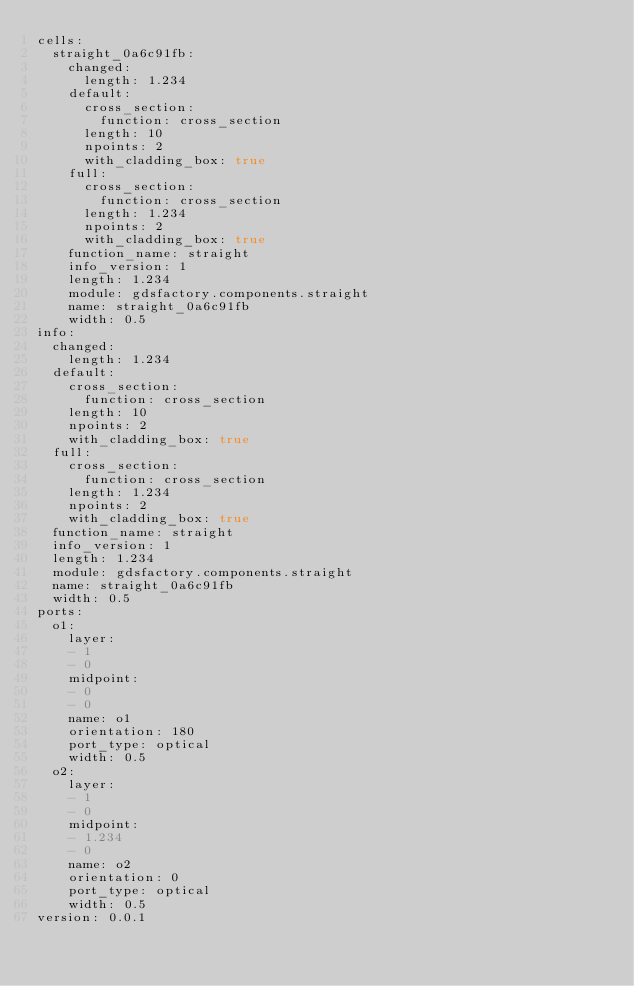<code> <loc_0><loc_0><loc_500><loc_500><_YAML_>cells:
  straight_0a6c91fb:
    changed:
      length: 1.234
    default:
      cross_section:
        function: cross_section
      length: 10
      npoints: 2
      with_cladding_box: true
    full:
      cross_section:
        function: cross_section
      length: 1.234
      npoints: 2
      with_cladding_box: true
    function_name: straight
    info_version: 1
    length: 1.234
    module: gdsfactory.components.straight
    name: straight_0a6c91fb
    width: 0.5
info:
  changed:
    length: 1.234
  default:
    cross_section:
      function: cross_section
    length: 10
    npoints: 2
    with_cladding_box: true
  full:
    cross_section:
      function: cross_section
    length: 1.234
    npoints: 2
    with_cladding_box: true
  function_name: straight
  info_version: 1
  length: 1.234
  module: gdsfactory.components.straight
  name: straight_0a6c91fb
  width: 0.5
ports:
  o1:
    layer:
    - 1
    - 0
    midpoint:
    - 0
    - 0
    name: o1
    orientation: 180
    port_type: optical
    width: 0.5
  o2:
    layer:
    - 1
    - 0
    midpoint:
    - 1.234
    - 0
    name: o2
    orientation: 0
    port_type: optical
    width: 0.5
version: 0.0.1
</code> 